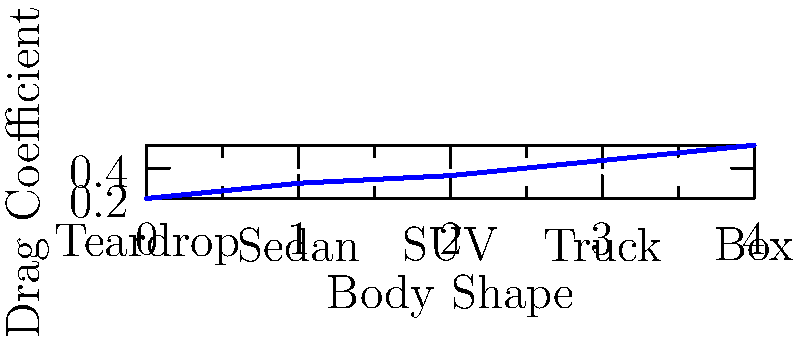As a financial analyst attending car auctions, you notice a trend in the pricing of vehicles based on their aerodynamic efficiency. The graph shows the drag coefficients for different car body shapes. Which body shape would likely command the highest price at auction due to its superior aerodynamic performance, and what is its approximate drag coefficient? To answer this question, we need to analyze the graph and understand the relationship between drag coefficient and aerodynamic efficiency:

1. The x-axis represents different car body shapes, from left to right: Teardrop, Sedan, SUV, Truck, and Box.
2. The y-axis represents the drag coefficient ($C_d$), where a lower value indicates better aerodynamic performance.
3. We can see that the line graph increases from left to right, meaning the drag coefficient increases.
4. The leftmost point on the graph represents the Teardrop shape, which has the lowest drag coefficient of approximately 0.2.
5. Lower drag coefficient means better aerodynamic efficiency, which generally translates to better fuel economy and performance.
6. In high-end automobile auctions, cars with superior aerodynamic performance are often valued higher due to their efficiency and potential for better performance.
7. Therefore, the Teardrop shape, with the lowest drag coefficient, would likely command the highest price at auction due to its superior aerodynamic performance.

The approximate drag coefficient for the Teardrop shape can be read from the graph as 0.2.
Answer: Teardrop shape, $C_d \approx 0.2$ 